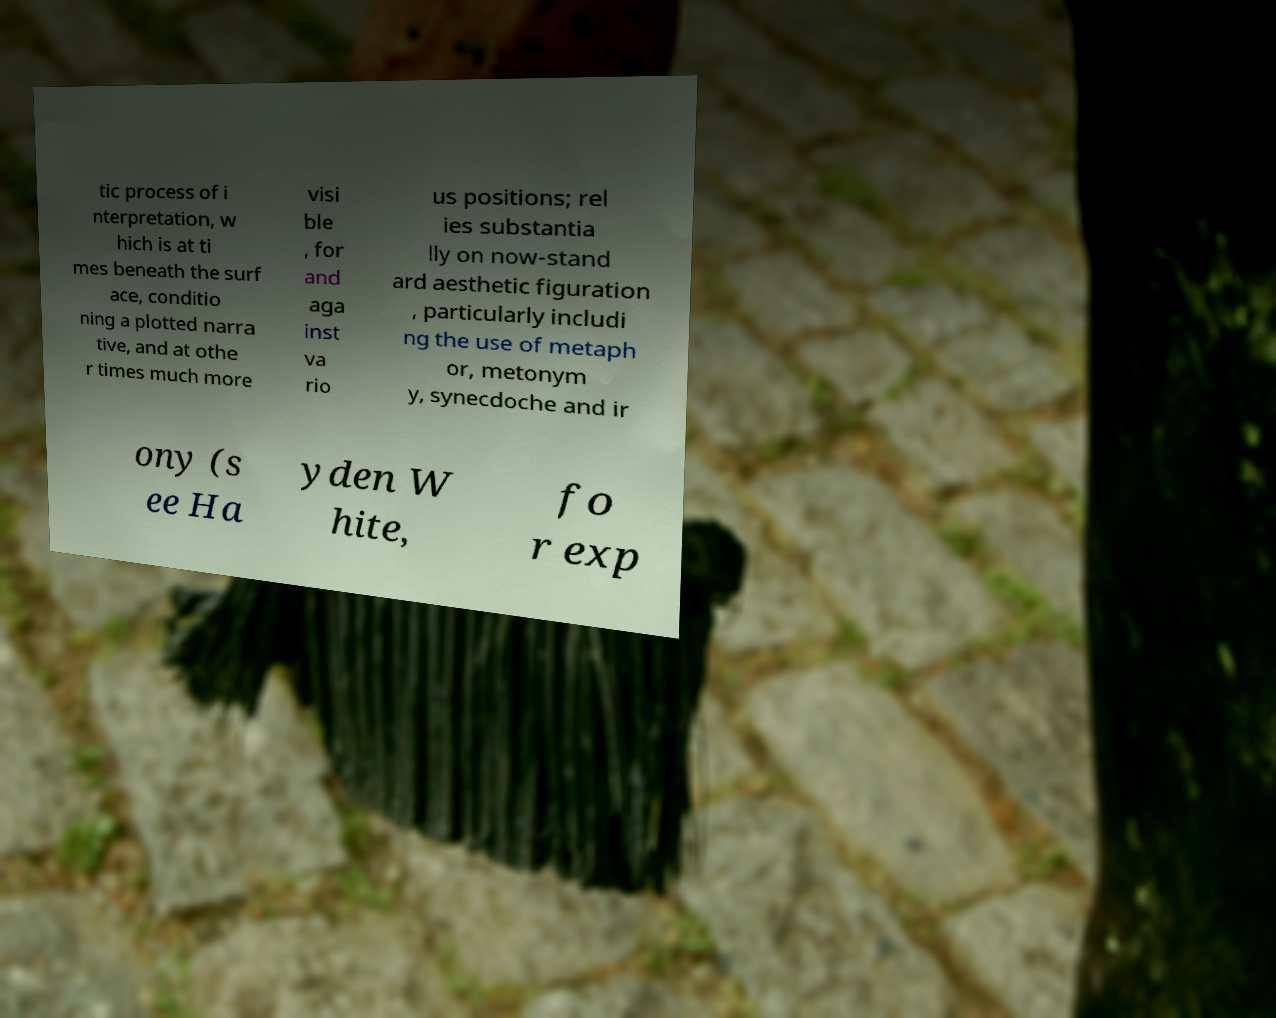What messages or text are displayed in this image? I need them in a readable, typed format. tic process of i nterpretation, w hich is at ti mes beneath the surf ace, conditio ning a plotted narra tive, and at othe r times much more visi ble , for and aga inst va rio us positions; rel ies substantia lly on now-stand ard aesthetic figuration , particularly includi ng the use of metaph or, metonym y, synecdoche and ir ony (s ee Ha yden W hite, fo r exp 